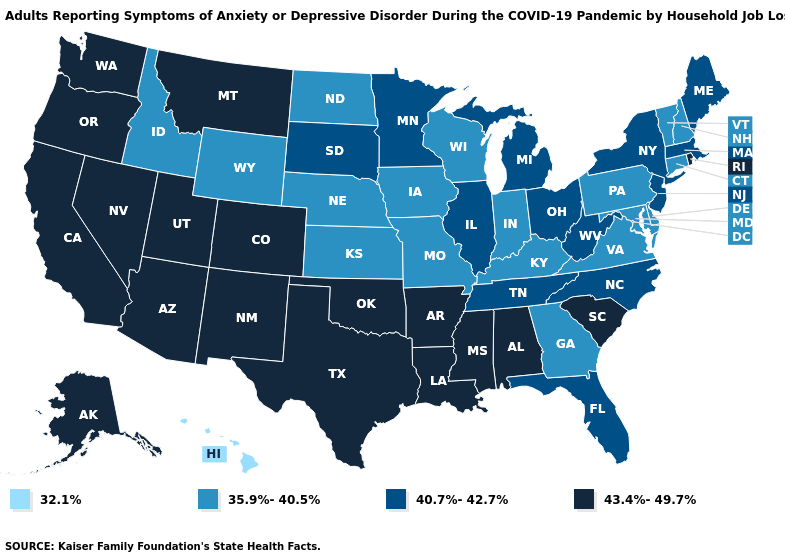Which states hav the highest value in the West?
Answer briefly. Alaska, Arizona, California, Colorado, Montana, Nevada, New Mexico, Oregon, Utah, Washington. Which states have the lowest value in the USA?
Give a very brief answer. Hawaii. Which states have the lowest value in the West?
Be succinct. Hawaii. What is the value of New Mexico?
Be succinct. 43.4%-49.7%. What is the value of Hawaii?
Concise answer only. 32.1%. What is the lowest value in states that border Maine?
Give a very brief answer. 35.9%-40.5%. What is the value of New Hampshire?
Write a very short answer. 35.9%-40.5%. Name the states that have a value in the range 32.1%?
Quick response, please. Hawaii. Does Colorado have the lowest value in the USA?
Concise answer only. No. Does the first symbol in the legend represent the smallest category?
Give a very brief answer. Yes. Name the states that have a value in the range 40.7%-42.7%?
Concise answer only. Florida, Illinois, Maine, Massachusetts, Michigan, Minnesota, New Jersey, New York, North Carolina, Ohio, South Dakota, Tennessee, West Virginia. How many symbols are there in the legend?
Short answer required. 4. What is the highest value in the USA?
Quick response, please. 43.4%-49.7%. Does West Virginia have the same value as Arkansas?
Concise answer only. No. Name the states that have a value in the range 40.7%-42.7%?
Write a very short answer. Florida, Illinois, Maine, Massachusetts, Michigan, Minnesota, New Jersey, New York, North Carolina, Ohio, South Dakota, Tennessee, West Virginia. 